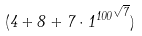<formula> <loc_0><loc_0><loc_500><loc_500>( 4 + 8 + 7 \cdot { 1 ^ { 1 0 0 } } ^ { \sqrt { 7 } } )</formula> 